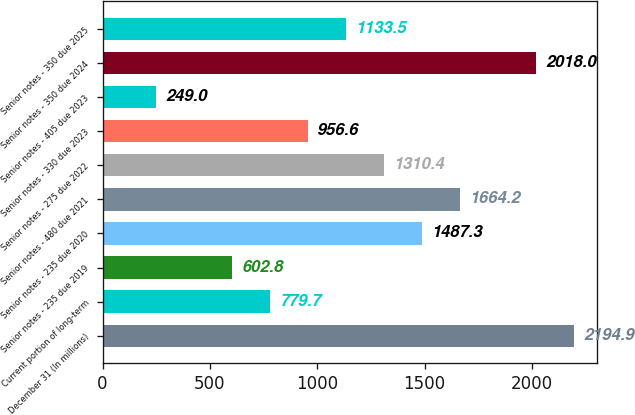<chart> <loc_0><loc_0><loc_500><loc_500><bar_chart><fcel>December 31 (In millions)<fcel>Current portion of long-term<fcel>Senior notes - 235 due 2019<fcel>Senior notes - 235 due 2020<fcel>Senior notes - 480 due 2021<fcel>Senior notes - 275 due 2022<fcel>Senior notes - 330 due 2023<fcel>Senior notes - 405 due 2023<fcel>Senior notes - 350 due 2024<fcel>Senior notes - 350 due 2025<nl><fcel>2194.9<fcel>779.7<fcel>602.8<fcel>1487.3<fcel>1664.2<fcel>1310.4<fcel>956.6<fcel>249<fcel>2018<fcel>1133.5<nl></chart> 